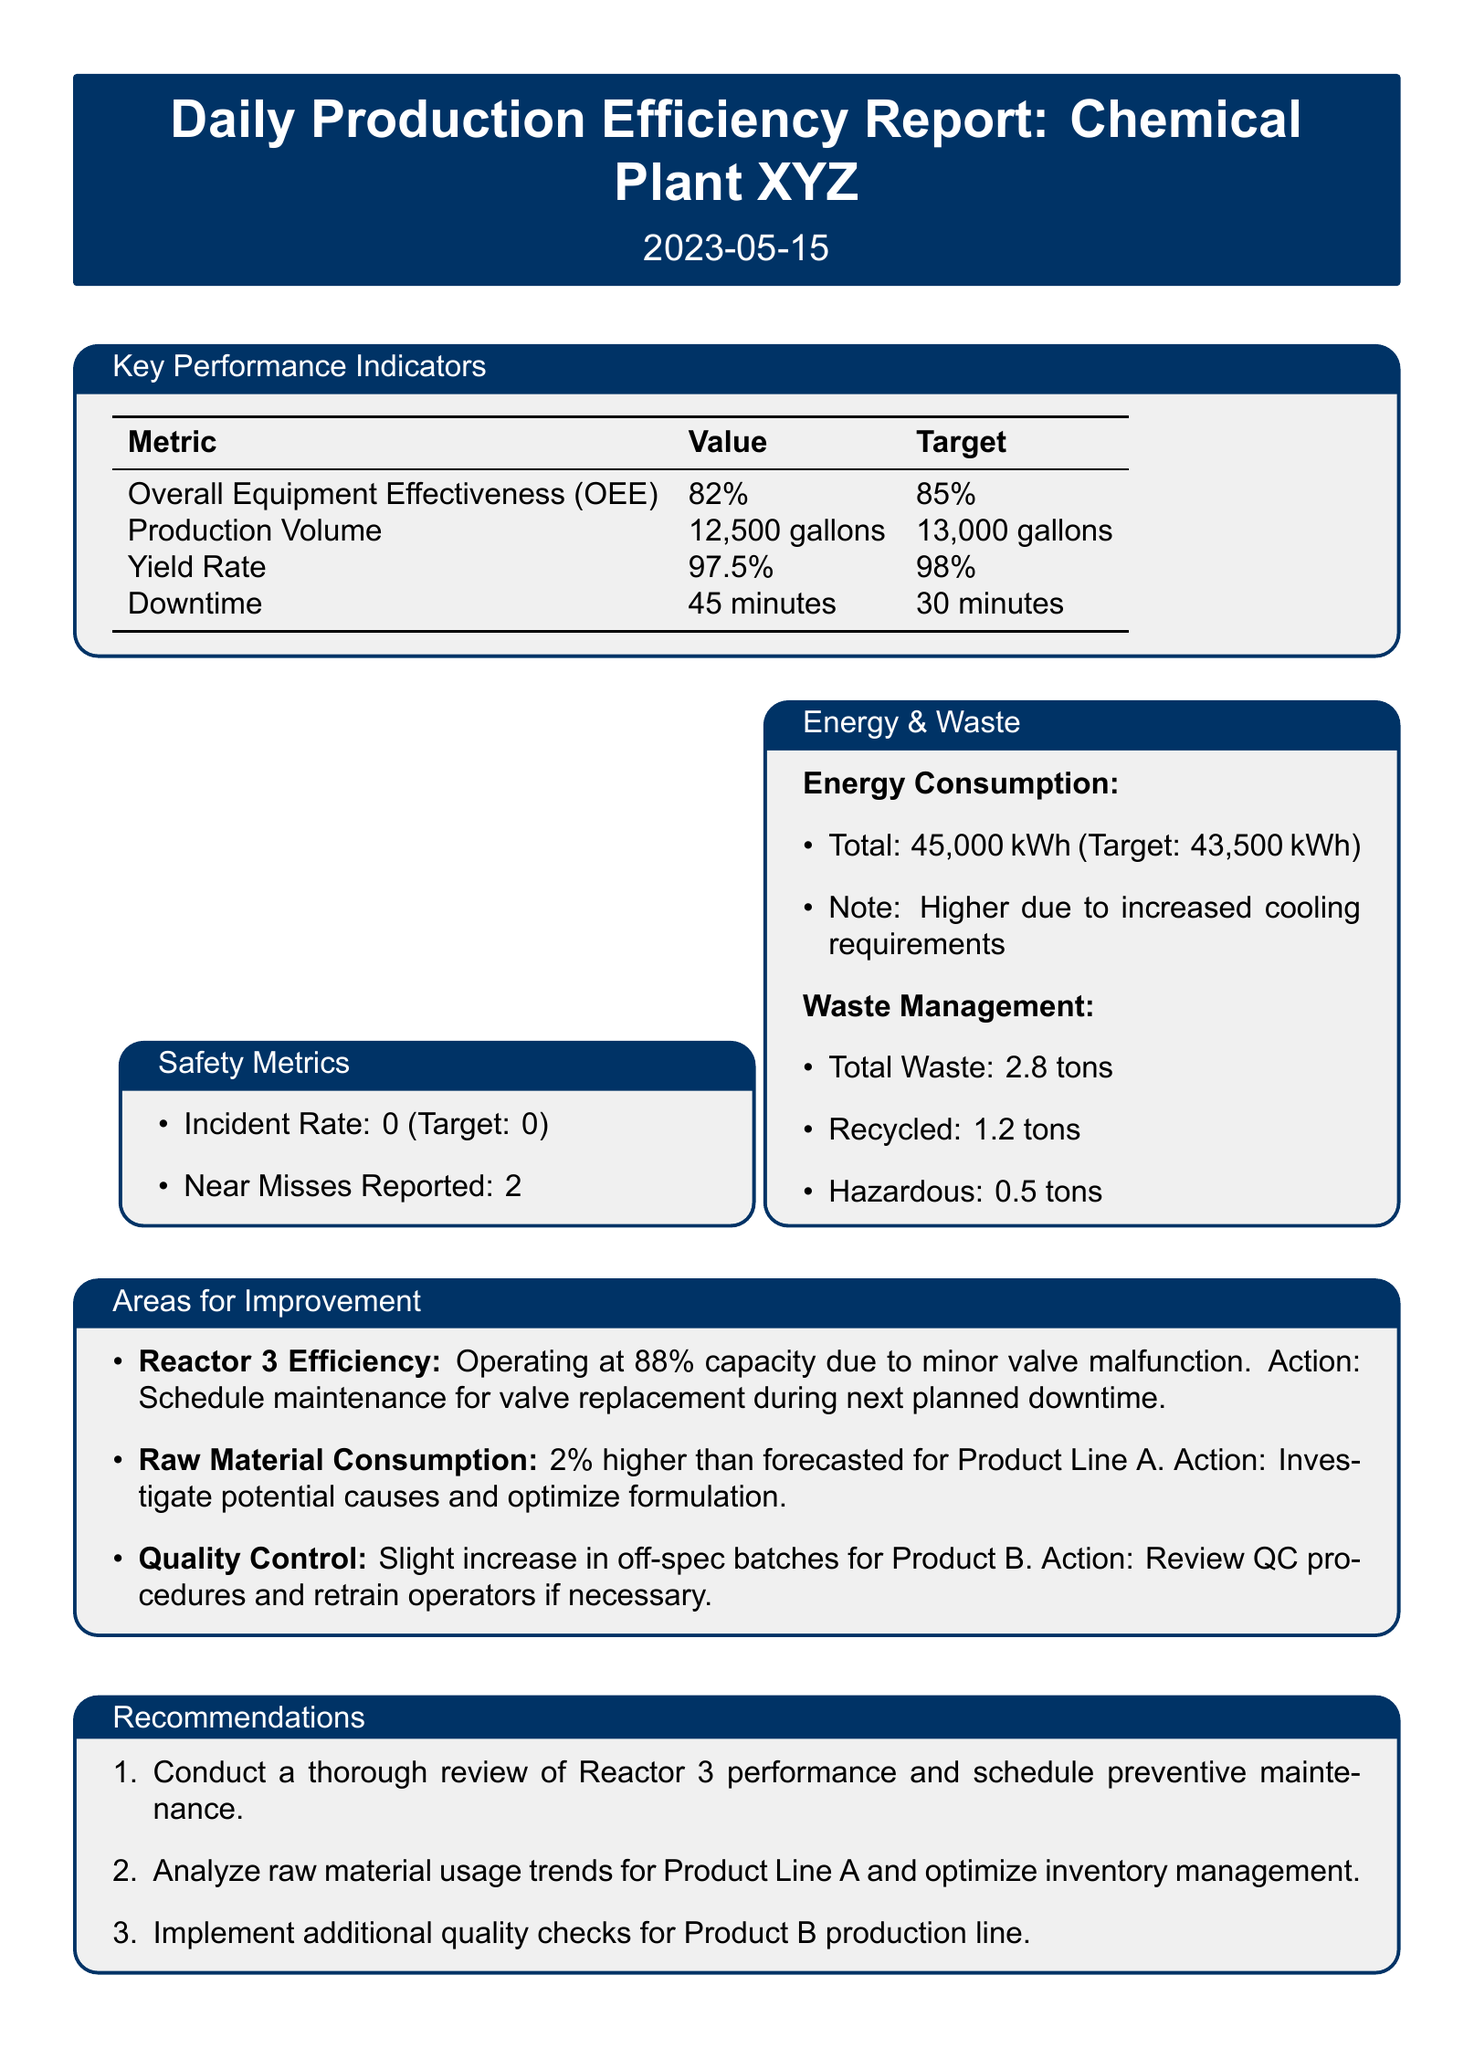What is the date of the report? The date of the report is specified at the beginning of the document.
Answer: 2023-05-15 What is the Overall Equipment Effectiveness (OEE)? The Overall Equipment Effectiveness (OEE) is listed in the Key Performance Indicators section of the document.
Answer: 82% What is the target for Production Volume? The target for Production Volume is mentioned alongside its value in the Key Performance Indicators.
Answer: 13,000 gallons What is the total waste generated? The total waste generated is provided in the Waste Management section of the document.
Answer: 2.8 tons What issue is Reactor 3 facing? The issue concerning Reactor 3 is detailed in the Areas for Improvement section.
Answer: Minor valve malfunction What action is recommended for optimizing raw material consumption? The recommended action for raw material consumption is found in the corresponding area for improvement.
Answer: Investigate potential causes and optimize formulation What was the energy consumption compared to the target? Information regarding energy consumption relative to its target is presented in the Energy & Waste section.
Answer: Higher due to increased cooling requirements How many near misses were reported? The number of near misses is found in the Safety Metrics section of the document.
Answer: 2 What is the yield rate target? The yield rate target is specified in the Key Performance Indicators section.
Answer: 98% 